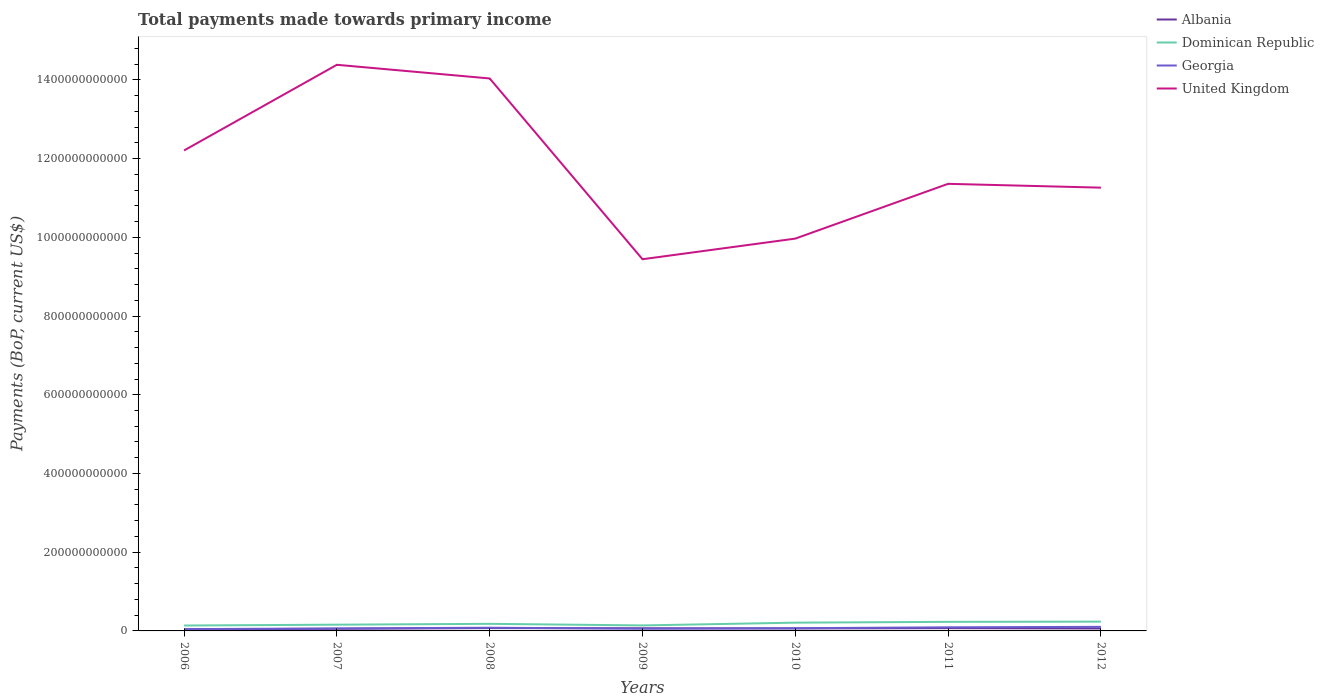Does the line corresponding to Dominican Republic intersect with the line corresponding to Albania?
Keep it short and to the point. No. Across all years, what is the maximum total payments made towards primary income in Georgia?
Your answer should be compact. 4.56e+09. In which year was the total payments made towards primary income in Albania maximum?
Give a very brief answer. 2006. What is the total total payments made towards primary income in United Kingdom in the graph?
Your answer should be very brief. -1.29e+11. What is the difference between the highest and the second highest total payments made towards primary income in Georgia?
Ensure brevity in your answer.  5.80e+09. Is the total payments made towards primary income in United Kingdom strictly greater than the total payments made towards primary income in Dominican Republic over the years?
Provide a short and direct response. No. How many lines are there?
Make the answer very short. 4. How many years are there in the graph?
Provide a succinct answer. 7. What is the difference between two consecutive major ticks on the Y-axis?
Ensure brevity in your answer.  2.00e+11. Are the values on the major ticks of Y-axis written in scientific E-notation?
Provide a succinct answer. No. Does the graph contain grids?
Provide a succinct answer. No. How are the legend labels stacked?
Provide a short and direct response. Vertical. What is the title of the graph?
Offer a terse response. Total payments made towards primary income. Does "Colombia" appear as one of the legend labels in the graph?
Your answer should be compact. No. What is the label or title of the Y-axis?
Offer a very short reply. Payments (BoP, current US$). What is the Payments (BoP, current US$) in Albania in 2006?
Ensure brevity in your answer.  4.14e+09. What is the Payments (BoP, current US$) of Dominican Republic in 2006?
Provide a succinct answer. 1.37e+1. What is the Payments (BoP, current US$) of Georgia in 2006?
Provide a short and direct response. 4.56e+09. What is the Payments (BoP, current US$) in United Kingdom in 2006?
Your answer should be compact. 1.22e+12. What is the Payments (BoP, current US$) in Albania in 2007?
Offer a very short reply. 5.43e+09. What is the Payments (BoP, current US$) of Dominican Republic in 2007?
Give a very brief answer. 1.59e+1. What is the Payments (BoP, current US$) in Georgia in 2007?
Your answer should be compact. 6.32e+09. What is the Payments (BoP, current US$) of United Kingdom in 2007?
Your answer should be very brief. 1.44e+12. What is the Payments (BoP, current US$) of Albania in 2008?
Your answer should be very brief. 7.15e+09. What is the Payments (BoP, current US$) of Dominican Republic in 2008?
Provide a succinct answer. 1.80e+1. What is the Payments (BoP, current US$) of Georgia in 2008?
Keep it short and to the point. 8.11e+09. What is the Payments (BoP, current US$) in United Kingdom in 2008?
Ensure brevity in your answer.  1.40e+12. What is the Payments (BoP, current US$) in Albania in 2009?
Provide a succinct answer. 6.60e+09. What is the Payments (BoP, current US$) in Dominican Republic in 2009?
Provide a succinct answer. 1.40e+1. What is the Payments (BoP, current US$) in Georgia in 2009?
Make the answer very short. 5.78e+09. What is the Payments (BoP, current US$) of United Kingdom in 2009?
Offer a very short reply. 9.44e+11. What is the Payments (BoP, current US$) of Albania in 2010?
Offer a very short reply. 6.28e+09. What is the Payments (BoP, current US$) in Dominican Republic in 2010?
Provide a short and direct response. 2.10e+1. What is the Payments (BoP, current US$) in Georgia in 2010?
Provide a short and direct response. 6.89e+09. What is the Payments (BoP, current US$) of United Kingdom in 2010?
Your answer should be compact. 9.97e+11. What is the Payments (BoP, current US$) in Albania in 2011?
Give a very brief answer. 7.01e+09. What is the Payments (BoP, current US$) in Dominican Republic in 2011?
Provide a short and direct response. 2.31e+1. What is the Payments (BoP, current US$) of Georgia in 2011?
Offer a very short reply. 9.17e+09. What is the Payments (BoP, current US$) in United Kingdom in 2011?
Make the answer very short. 1.14e+12. What is the Payments (BoP, current US$) in Albania in 2012?
Provide a short and direct response. 6.19e+09. What is the Payments (BoP, current US$) in Dominican Republic in 2012?
Ensure brevity in your answer.  2.36e+1. What is the Payments (BoP, current US$) of Georgia in 2012?
Provide a succinct answer. 1.04e+1. What is the Payments (BoP, current US$) in United Kingdom in 2012?
Provide a short and direct response. 1.13e+12. Across all years, what is the maximum Payments (BoP, current US$) of Albania?
Your answer should be very brief. 7.15e+09. Across all years, what is the maximum Payments (BoP, current US$) of Dominican Republic?
Give a very brief answer. 2.36e+1. Across all years, what is the maximum Payments (BoP, current US$) in Georgia?
Your response must be concise. 1.04e+1. Across all years, what is the maximum Payments (BoP, current US$) in United Kingdom?
Make the answer very short. 1.44e+12. Across all years, what is the minimum Payments (BoP, current US$) in Albania?
Keep it short and to the point. 4.14e+09. Across all years, what is the minimum Payments (BoP, current US$) of Dominican Republic?
Keep it short and to the point. 1.37e+1. Across all years, what is the minimum Payments (BoP, current US$) in Georgia?
Your answer should be very brief. 4.56e+09. Across all years, what is the minimum Payments (BoP, current US$) in United Kingdom?
Keep it short and to the point. 9.44e+11. What is the total Payments (BoP, current US$) in Albania in the graph?
Provide a succinct answer. 4.28e+1. What is the total Payments (BoP, current US$) of Dominican Republic in the graph?
Make the answer very short. 1.29e+11. What is the total Payments (BoP, current US$) in Georgia in the graph?
Make the answer very short. 5.12e+1. What is the total Payments (BoP, current US$) in United Kingdom in the graph?
Your answer should be compact. 8.27e+12. What is the difference between the Payments (BoP, current US$) of Albania in 2006 and that in 2007?
Make the answer very short. -1.29e+09. What is the difference between the Payments (BoP, current US$) in Dominican Republic in 2006 and that in 2007?
Your response must be concise. -2.16e+09. What is the difference between the Payments (BoP, current US$) of Georgia in 2006 and that in 2007?
Keep it short and to the point. -1.77e+09. What is the difference between the Payments (BoP, current US$) of United Kingdom in 2006 and that in 2007?
Make the answer very short. -2.18e+11. What is the difference between the Payments (BoP, current US$) of Albania in 2006 and that in 2008?
Give a very brief answer. -3.01e+09. What is the difference between the Payments (BoP, current US$) of Dominican Republic in 2006 and that in 2008?
Keep it short and to the point. -4.31e+09. What is the difference between the Payments (BoP, current US$) in Georgia in 2006 and that in 2008?
Give a very brief answer. -3.56e+09. What is the difference between the Payments (BoP, current US$) of United Kingdom in 2006 and that in 2008?
Offer a terse response. -1.83e+11. What is the difference between the Payments (BoP, current US$) in Albania in 2006 and that in 2009?
Provide a succinct answer. -2.46e+09. What is the difference between the Payments (BoP, current US$) in Dominican Republic in 2006 and that in 2009?
Offer a very short reply. -2.64e+08. What is the difference between the Payments (BoP, current US$) of Georgia in 2006 and that in 2009?
Keep it short and to the point. -1.22e+09. What is the difference between the Payments (BoP, current US$) of United Kingdom in 2006 and that in 2009?
Give a very brief answer. 2.76e+11. What is the difference between the Payments (BoP, current US$) of Albania in 2006 and that in 2010?
Your answer should be compact. -2.14e+09. What is the difference between the Payments (BoP, current US$) of Dominican Republic in 2006 and that in 2010?
Ensure brevity in your answer.  -7.26e+09. What is the difference between the Payments (BoP, current US$) in Georgia in 2006 and that in 2010?
Your answer should be very brief. -2.33e+09. What is the difference between the Payments (BoP, current US$) in United Kingdom in 2006 and that in 2010?
Keep it short and to the point. 2.24e+11. What is the difference between the Payments (BoP, current US$) of Albania in 2006 and that in 2011?
Offer a very short reply. -2.87e+09. What is the difference between the Payments (BoP, current US$) of Dominican Republic in 2006 and that in 2011?
Provide a succinct answer. -9.36e+09. What is the difference between the Payments (BoP, current US$) in Georgia in 2006 and that in 2011?
Offer a terse response. -4.61e+09. What is the difference between the Payments (BoP, current US$) of United Kingdom in 2006 and that in 2011?
Offer a very short reply. 8.48e+1. What is the difference between the Payments (BoP, current US$) of Albania in 2006 and that in 2012?
Give a very brief answer. -2.05e+09. What is the difference between the Payments (BoP, current US$) in Dominican Republic in 2006 and that in 2012?
Provide a short and direct response. -9.91e+09. What is the difference between the Payments (BoP, current US$) in Georgia in 2006 and that in 2012?
Provide a succinct answer. -5.80e+09. What is the difference between the Payments (BoP, current US$) of United Kingdom in 2006 and that in 2012?
Give a very brief answer. 9.45e+1. What is the difference between the Payments (BoP, current US$) in Albania in 2007 and that in 2008?
Your response must be concise. -1.72e+09. What is the difference between the Payments (BoP, current US$) in Dominican Republic in 2007 and that in 2008?
Provide a short and direct response. -2.15e+09. What is the difference between the Payments (BoP, current US$) in Georgia in 2007 and that in 2008?
Provide a short and direct response. -1.79e+09. What is the difference between the Payments (BoP, current US$) of United Kingdom in 2007 and that in 2008?
Offer a terse response. 3.47e+1. What is the difference between the Payments (BoP, current US$) in Albania in 2007 and that in 2009?
Offer a very short reply. -1.17e+09. What is the difference between the Payments (BoP, current US$) of Dominican Republic in 2007 and that in 2009?
Give a very brief answer. 1.90e+09. What is the difference between the Payments (BoP, current US$) of Georgia in 2007 and that in 2009?
Offer a terse response. 5.46e+08. What is the difference between the Payments (BoP, current US$) in United Kingdom in 2007 and that in 2009?
Offer a terse response. 4.94e+11. What is the difference between the Payments (BoP, current US$) in Albania in 2007 and that in 2010?
Keep it short and to the point. -8.50e+08. What is the difference between the Payments (BoP, current US$) in Dominican Republic in 2007 and that in 2010?
Give a very brief answer. -5.10e+09. What is the difference between the Payments (BoP, current US$) in Georgia in 2007 and that in 2010?
Ensure brevity in your answer.  -5.60e+08. What is the difference between the Payments (BoP, current US$) of United Kingdom in 2007 and that in 2010?
Your response must be concise. 4.42e+11. What is the difference between the Payments (BoP, current US$) in Albania in 2007 and that in 2011?
Provide a succinct answer. -1.58e+09. What is the difference between the Payments (BoP, current US$) of Dominican Republic in 2007 and that in 2011?
Offer a terse response. -7.20e+09. What is the difference between the Payments (BoP, current US$) in Georgia in 2007 and that in 2011?
Offer a terse response. -2.84e+09. What is the difference between the Payments (BoP, current US$) in United Kingdom in 2007 and that in 2011?
Offer a terse response. 3.02e+11. What is the difference between the Payments (BoP, current US$) in Albania in 2007 and that in 2012?
Your answer should be very brief. -7.60e+08. What is the difference between the Payments (BoP, current US$) in Dominican Republic in 2007 and that in 2012?
Make the answer very short. -7.75e+09. What is the difference between the Payments (BoP, current US$) in Georgia in 2007 and that in 2012?
Offer a terse response. -4.03e+09. What is the difference between the Payments (BoP, current US$) in United Kingdom in 2007 and that in 2012?
Ensure brevity in your answer.  3.12e+11. What is the difference between the Payments (BoP, current US$) in Albania in 2008 and that in 2009?
Your answer should be very brief. 5.51e+08. What is the difference between the Payments (BoP, current US$) in Dominican Republic in 2008 and that in 2009?
Your answer should be compact. 4.04e+09. What is the difference between the Payments (BoP, current US$) in Georgia in 2008 and that in 2009?
Provide a short and direct response. 2.34e+09. What is the difference between the Payments (BoP, current US$) in United Kingdom in 2008 and that in 2009?
Your answer should be very brief. 4.59e+11. What is the difference between the Payments (BoP, current US$) in Albania in 2008 and that in 2010?
Your answer should be compact. 8.69e+08. What is the difference between the Payments (BoP, current US$) in Dominican Republic in 2008 and that in 2010?
Your answer should be compact. -2.95e+09. What is the difference between the Payments (BoP, current US$) in Georgia in 2008 and that in 2010?
Make the answer very short. 1.23e+09. What is the difference between the Payments (BoP, current US$) of United Kingdom in 2008 and that in 2010?
Offer a very short reply. 4.07e+11. What is the difference between the Payments (BoP, current US$) of Albania in 2008 and that in 2011?
Your answer should be compact. 1.39e+08. What is the difference between the Payments (BoP, current US$) of Dominican Republic in 2008 and that in 2011?
Make the answer very short. -5.05e+09. What is the difference between the Payments (BoP, current US$) in Georgia in 2008 and that in 2011?
Give a very brief answer. -1.05e+09. What is the difference between the Payments (BoP, current US$) in United Kingdom in 2008 and that in 2011?
Your answer should be compact. 2.68e+11. What is the difference between the Payments (BoP, current US$) of Albania in 2008 and that in 2012?
Give a very brief answer. 9.60e+08. What is the difference between the Payments (BoP, current US$) in Dominican Republic in 2008 and that in 2012?
Keep it short and to the point. -5.60e+09. What is the difference between the Payments (BoP, current US$) of Georgia in 2008 and that in 2012?
Provide a short and direct response. -2.24e+09. What is the difference between the Payments (BoP, current US$) in United Kingdom in 2008 and that in 2012?
Give a very brief answer. 2.77e+11. What is the difference between the Payments (BoP, current US$) of Albania in 2009 and that in 2010?
Keep it short and to the point. 3.18e+08. What is the difference between the Payments (BoP, current US$) of Dominican Republic in 2009 and that in 2010?
Ensure brevity in your answer.  -7.00e+09. What is the difference between the Payments (BoP, current US$) of Georgia in 2009 and that in 2010?
Offer a terse response. -1.11e+09. What is the difference between the Payments (BoP, current US$) of United Kingdom in 2009 and that in 2010?
Keep it short and to the point. -5.24e+1. What is the difference between the Payments (BoP, current US$) in Albania in 2009 and that in 2011?
Make the answer very short. -4.12e+08. What is the difference between the Payments (BoP, current US$) in Dominican Republic in 2009 and that in 2011?
Your answer should be very brief. -9.09e+09. What is the difference between the Payments (BoP, current US$) of Georgia in 2009 and that in 2011?
Provide a short and direct response. -3.39e+09. What is the difference between the Payments (BoP, current US$) of United Kingdom in 2009 and that in 2011?
Your response must be concise. -1.92e+11. What is the difference between the Payments (BoP, current US$) in Albania in 2009 and that in 2012?
Ensure brevity in your answer.  4.09e+08. What is the difference between the Payments (BoP, current US$) of Dominican Republic in 2009 and that in 2012?
Your answer should be very brief. -9.65e+09. What is the difference between the Payments (BoP, current US$) in Georgia in 2009 and that in 2012?
Give a very brief answer. -4.58e+09. What is the difference between the Payments (BoP, current US$) in United Kingdom in 2009 and that in 2012?
Keep it short and to the point. -1.82e+11. What is the difference between the Payments (BoP, current US$) of Albania in 2010 and that in 2011?
Provide a succinct answer. -7.30e+08. What is the difference between the Payments (BoP, current US$) in Dominican Republic in 2010 and that in 2011?
Ensure brevity in your answer.  -2.10e+09. What is the difference between the Payments (BoP, current US$) in Georgia in 2010 and that in 2011?
Provide a short and direct response. -2.28e+09. What is the difference between the Payments (BoP, current US$) in United Kingdom in 2010 and that in 2011?
Offer a terse response. -1.39e+11. What is the difference between the Payments (BoP, current US$) of Albania in 2010 and that in 2012?
Your answer should be compact. 9.08e+07. What is the difference between the Payments (BoP, current US$) of Dominican Republic in 2010 and that in 2012?
Your answer should be very brief. -2.65e+09. What is the difference between the Payments (BoP, current US$) of Georgia in 2010 and that in 2012?
Make the answer very short. -3.47e+09. What is the difference between the Payments (BoP, current US$) in United Kingdom in 2010 and that in 2012?
Make the answer very short. -1.29e+11. What is the difference between the Payments (BoP, current US$) of Albania in 2011 and that in 2012?
Your response must be concise. 8.21e+08. What is the difference between the Payments (BoP, current US$) of Dominican Republic in 2011 and that in 2012?
Ensure brevity in your answer.  -5.53e+08. What is the difference between the Payments (BoP, current US$) in Georgia in 2011 and that in 2012?
Your answer should be very brief. -1.19e+09. What is the difference between the Payments (BoP, current US$) in United Kingdom in 2011 and that in 2012?
Ensure brevity in your answer.  9.73e+09. What is the difference between the Payments (BoP, current US$) of Albania in 2006 and the Payments (BoP, current US$) of Dominican Republic in 2007?
Make the answer very short. -1.17e+1. What is the difference between the Payments (BoP, current US$) in Albania in 2006 and the Payments (BoP, current US$) in Georgia in 2007?
Your response must be concise. -2.18e+09. What is the difference between the Payments (BoP, current US$) in Albania in 2006 and the Payments (BoP, current US$) in United Kingdom in 2007?
Your answer should be very brief. -1.43e+12. What is the difference between the Payments (BoP, current US$) of Dominican Republic in 2006 and the Payments (BoP, current US$) of Georgia in 2007?
Give a very brief answer. 7.40e+09. What is the difference between the Payments (BoP, current US$) of Dominican Republic in 2006 and the Payments (BoP, current US$) of United Kingdom in 2007?
Provide a succinct answer. -1.42e+12. What is the difference between the Payments (BoP, current US$) of Georgia in 2006 and the Payments (BoP, current US$) of United Kingdom in 2007?
Provide a succinct answer. -1.43e+12. What is the difference between the Payments (BoP, current US$) of Albania in 2006 and the Payments (BoP, current US$) of Dominican Republic in 2008?
Offer a terse response. -1.39e+1. What is the difference between the Payments (BoP, current US$) in Albania in 2006 and the Payments (BoP, current US$) in Georgia in 2008?
Give a very brief answer. -3.97e+09. What is the difference between the Payments (BoP, current US$) of Albania in 2006 and the Payments (BoP, current US$) of United Kingdom in 2008?
Keep it short and to the point. -1.40e+12. What is the difference between the Payments (BoP, current US$) in Dominican Republic in 2006 and the Payments (BoP, current US$) in Georgia in 2008?
Provide a succinct answer. 5.61e+09. What is the difference between the Payments (BoP, current US$) of Dominican Republic in 2006 and the Payments (BoP, current US$) of United Kingdom in 2008?
Keep it short and to the point. -1.39e+12. What is the difference between the Payments (BoP, current US$) in Georgia in 2006 and the Payments (BoP, current US$) in United Kingdom in 2008?
Provide a short and direct response. -1.40e+12. What is the difference between the Payments (BoP, current US$) of Albania in 2006 and the Payments (BoP, current US$) of Dominican Republic in 2009?
Your response must be concise. -9.84e+09. What is the difference between the Payments (BoP, current US$) of Albania in 2006 and the Payments (BoP, current US$) of Georgia in 2009?
Offer a very short reply. -1.64e+09. What is the difference between the Payments (BoP, current US$) of Albania in 2006 and the Payments (BoP, current US$) of United Kingdom in 2009?
Your response must be concise. -9.40e+11. What is the difference between the Payments (BoP, current US$) in Dominican Republic in 2006 and the Payments (BoP, current US$) in Georgia in 2009?
Give a very brief answer. 7.94e+09. What is the difference between the Payments (BoP, current US$) in Dominican Republic in 2006 and the Payments (BoP, current US$) in United Kingdom in 2009?
Offer a terse response. -9.31e+11. What is the difference between the Payments (BoP, current US$) of Georgia in 2006 and the Payments (BoP, current US$) of United Kingdom in 2009?
Your answer should be very brief. -9.40e+11. What is the difference between the Payments (BoP, current US$) in Albania in 2006 and the Payments (BoP, current US$) in Dominican Republic in 2010?
Your answer should be compact. -1.68e+1. What is the difference between the Payments (BoP, current US$) in Albania in 2006 and the Payments (BoP, current US$) in Georgia in 2010?
Keep it short and to the point. -2.74e+09. What is the difference between the Payments (BoP, current US$) of Albania in 2006 and the Payments (BoP, current US$) of United Kingdom in 2010?
Keep it short and to the point. -9.93e+11. What is the difference between the Payments (BoP, current US$) of Dominican Republic in 2006 and the Payments (BoP, current US$) of Georgia in 2010?
Provide a short and direct response. 6.84e+09. What is the difference between the Payments (BoP, current US$) in Dominican Republic in 2006 and the Payments (BoP, current US$) in United Kingdom in 2010?
Provide a succinct answer. -9.83e+11. What is the difference between the Payments (BoP, current US$) of Georgia in 2006 and the Payments (BoP, current US$) of United Kingdom in 2010?
Keep it short and to the point. -9.92e+11. What is the difference between the Payments (BoP, current US$) of Albania in 2006 and the Payments (BoP, current US$) of Dominican Republic in 2011?
Give a very brief answer. -1.89e+1. What is the difference between the Payments (BoP, current US$) of Albania in 2006 and the Payments (BoP, current US$) of Georgia in 2011?
Your answer should be compact. -5.03e+09. What is the difference between the Payments (BoP, current US$) in Albania in 2006 and the Payments (BoP, current US$) in United Kingdom in 2011?
Make the answer very short. -1.13e+12. What is the difference between the Payments (BoP, current US$) of Dominican Republic in 2006 and the Payments (BoP, current US$) of Georgia in 2011?
Your answer should be compact. 4.55e+09. What is the difference between the Payments (BoP, current US$) of Dominican Republic in 2006 and the Payments (BoP, current US$) of United Kingdom in 2011?
Ensure brevity in your answer.  -1.12e+12. What is the difference between the Payments (BoP, current US$) in Georgia in 2006 and the Payments (BoP, current US$) in United Kingdom in 2011?
Your response must be concise. -1.13e+12. What is the difference between the Payments (BoP, current US$) of Albania in 2006 and the Payments (BoP, current US$) of Dominican Republic in 2012?
Provide a short and direct response. -1.95e+1. What is the difference between the Payments (BoP, current US$) in Albania in 2006 and the Payments (BoP, current US$) in Georgia in 2012?
Make the answer very short. -6.21e+09. What is the difference between the Payments (BoP, current US$) in Albania in 2006 and the Payments (BoP, current US$) in United Kingdom in 2012?
Offer a terse response. -1.12e+12. What is the difference between the Payments (BoP, current US$) of Dominican Republic in 2006 and the Payments (BoP, current US$) of Georgia in 2012?
Provide a succinct answer. 3.37e+09. What is the difference between the Payments (BoP, current US$) in Dominican Republic in 2006 and the Payments (BoP, current US$) in United Kingdom in 2012?
Ensure brevity in your answer.  -1.11e+12. What is the difference between the Payments (BoP, current US$) in Georgia in 2006 and the Payments (BoP, current US$) in United Kingdom in 2012?
Your response must be concise. -1.12e+12. What is the difference between the Payments (BoP, current US$) of Albania in 2007 and the Payments (BoP, current US$) of Dominican Republic in 2008?
Provide a succinct answer. -1.26e+1. What is the difference between the Payments (BoP, current US$) of Albania in 2007 and the Payments (BoP, current US$) of Georgia in 2008?
Give a very brief answer. -2.69e+09. What is the difference between the Payments (BoP, current US$) of Albania in 2007 and the Payments (BoP, current US$) of United Kingdom in 2008?
Your answer should be compact. -1.40e+12. What is the difference between the Payments (BoP, current US$) in Dominican Republic in 2007 and the Payments (BoP, current US$) in Georgia in 2008?
Provide a succinct answer. 7.77e+09. What is the difference between the Payments (BoP, current US$) of Dominican Republic in 2007 and the Payments (BoP, current US$) of United Kingdom in 2008?
Give a very brief answer. -1.39e+12. What is the difference between the Payments (BoP, current US$) of Georgia in 2007 and the Payments (BoP, current US$) of United Kingdom in 2008?
Offer a terse response. -1.40e+12. What is the difference between the Payments (BoP, current US$) in Albania in 2007 and the Payments (BoP, current US$) in Dominican Republic in 2009?
Your response must be concise. -8.56e+09. What is the difference between the Payments (BoP, current US$) of Albania in 2007 and the Payments (BoP, current US$) of Georgia in 2009?
Make the answer very short. -3.50e+08. What is the difference between the Payments (BoP, current US$) of Albania in 2007 and the Payments (BoP, current US$) of United Kingdom in 2009?
Give a very brief answer. -9.39e+11. What is the difference between the Payments (BoP, current US$) of Dominican Republic in 2007 and the Payments (BoP, current US$) of Georgia in 2009?
Offer a very short reply. 1.01e+1. What is the difference between the Payments (BoP, current US$) of Dominican Republic in 2007 and the Payments (BoP, current US$) of United Kingdom in 2009?
Your answer should be compact. -9.28e+11. What is the difference between the Payments (BoP, current US$) of Georgia in 2007 and the Payments (BoP, current US$) of United Kingdom in 2009?
Offer a very short reply. -9.38e+11. What is the difference between the Payments (BoP, current US$) of Albania in 2007 and the Payments (BoP, current US$) of Dominican Republic in 2010?
Your answer should be very brief. -1.56e+1. What is the difference between the Payments (BoP, current US$) in Albania in 2007 and the Payments (BoP, current US$) in Georgia in 2010?
Offer a terse response. -1.46e+09. What is the difference between the Payments (BoP, current US$) in Albania in 2007 and the Payments (BoP, current US$) in United Kingdom in 2010?
Your answer should be very brief. -9.91e+11. What is the difference between the Payments (BoP, current US$) in Dominican Republic in 2007 and the Payments (BoP, current US$) in Georgia in 2010?
Provide a succinct answer. 9.00e+09. What is the difference between the Payments (BoP, current US$) of Dominican Republic in 2007 and the Payments (BoP, current US$) of United Kingdom in 2010?
Your answer should be very brief. -9.81e+11. What is the difference between the Payments (BoP, current US$) of Georgia in 2007 and the Payments (BoP, current US$) of United Kingdom in 2010?
Your answer should be very brief. -9.90e+11. What is the difference between the Payments (BoP, current US$) of Albania in 2007 and the Payments (BoP, current US$) of Dominican Republic in 2011?
Your answer should be compact. -1.77e+1. What is the difference between the Payments (BoP, current US$) in Albania in 2007 and the Payments (BoP, current US$) in Georgia in 2011?
Your answer should be very brief. -3.74e+09. What is the difference between the Payments (BoP, current US$) in Albania in 2007 and the Payments (BoP, current US$) in United Kingdom in 2011?
Your answer should be very brief. -1.13e+12. What is the difference between the Payments (BoP, current US$) in Dominican Republic in 2007 and the Payments (BoP, current US$) in Georgia in 2011?
Offer a terse response. 6.71e+09. What is the difference between the Payments (BoP, current US$) in Dominican Republic in 2007 and the Payments (BoP, current US$) in United Kingdom in 2011?
Your answer should be compact. -1.12e+12. What is the difference between the Payments (BoP, current US$) in Georgia in 2007 and the Payments (BoP, current US$) in United Kingdom in 2011?
Your answer should be very brief. -1.13e+12. What is the difference between the Payments (BoP, current US$) in Albania in 2007 and the Payments (BoP, current US$) in Dominican Republic in 2012?
Your answer should be compact. -1.82e+1. What is the difference between the Payments (BoP, current US$) of Albania in 2007 and the Payments (BoP, current US$) of Georgia in 2012?
Make the answer very short. -4.93e+09. What is the difference between the Payments (BoP, current US$) in Albania in 2007 and the Payments (BoP, current US$) in United Kingdom in 2012?
Keep it short and to the point. -1.12e+12. What is the difference between the Payments (BoP, current US$) in Dominican Republic in 2007 and the Payments (BoP, current US$) in Georgia in 2012?
Give a very brief answer. 5.52e+09. What is the difference between the Payments (BoP, current US$) of Dominican Republic in 2007 and the Payments (BoP, current US$) of United Kingdom in 2012?
Provide a succinct answer. -1.11e+12. What is the difference between the Payments (BoP, current US$) of Georgia in 2007 and the Payments (BoP, current US$) of United Kingdom in 2012?
Your answer should be very brief. -1.12e+12. What is the difference between the Payments (BoP, current US$) in Albania in 2008 and the Payments (BoP, current US$) in Dominican Republic in 2009?
Your answer should be very brief. -6.84e+09. What is the difference between the Payments (BoP, current US$) of Albania in 2008 and the Payments (BoP, current US$) of Georgia in 2009?
Your answer should be compact. 1.37e+09. What is the difference between the Payments (BoP, current US$) in Albania in 2008 and the Payments (BoP, current US$) in United Kingdom in 2009?
Provide a short and direct response. -9.37e+11. What is the difference between the Payments (BoP, current US$) of Dominican Republic in 2008 and the Payments (BoP, current US$) of Georgia in 2009?
Make the answer very short. 1.23e+1. What is the difference between the Payments (BoP, current US$) in Dominican Republic in 2008 and the Payments (BoP, current US$) in United Kingdom in 2009?
Make the answer very short. -9.26e+11. What is the difference between the Payments (BoP, current US$) of Georgia in 2008 and the Payments (BoP, current US$) of United Kingdom in 2009?
Your answer should be compact. -9.36e+11. What is the difference between the Payments (BoP, current US$) of Albania in 2008 and the Payments (BoP, current US$) of Dominican Republic in 2010?
Provide a succinct answer. -1.38e+1. What is the difference between the Payments (BoP, current US$) in Albania in 2008 and the Payments (BoP, current US$) in Georgia in 2010?
Ensure brevity in your answer.  2.64e+08. What is the difference between the Payments (BoP, current US$) of Albania in 2008 and the Payments (BoP, current US$) of United Kingdom in 2010?
Offer a very short reply. -9.90e+11. What is the difference between the Payments (BoP, current US$) of Dominican Republic in 2008 and the Payments (BoP, current US$) of Georgia in 2010?
Offer a very short reply. 1.11e+1. What is the difference between the Payments (BoP, current US$) of Dominican Republic in 2008 and the Payments (BoP, current US$) of United Kingdom in 2010?
Offer a terse response. -9.79e+11. What is the difference between the Payments (BoP, current US$) in Georgia in 2008 and the Payments (BoP, current US$) in United Kingdom in 2010?
Provide a succinct answer. -9.89e+11. What is the difference between the Payments (BoP, current US$) in Albania in 2008 and the Payments (BoP, current US$) in Dominican Republic in 2011?
Make the answer very short. -1.59e+1. What is the difference between the Payments (BoP, current US$) of Albania in 2008 and the Payments (BoP, current US$) of Georgia in 2011?
Give a very brief answer. -2.02e+09. What is the difference between the Payments (BoP, current US$) of Albania in 2008 and the Payments (BoP, current US$) of United Kingdom in 2011?
Provide a short and direct response. -1.13e+12. What is the difference between the Payments (BoP, current US$) in Dominican Republic in 2008 and the Payments (BoP, current US$) in Georgia in 2011?
Provide a short and direct response. 8.86e+09. What is the difference between the Payments (BoP, current US$) of Dominican Republic in 2008 and the Payments (BoP, current US$) of United Kingdom in 2011?
Give a very brief answer. -1.12e+12. What is the difference between the Payments (BoP, current US$) of Georgia in 2008 and the Payments (BoP, current US$) of United Kingdom in 2011?
Your answer should be very brief. -1.13e+12. What is the difference between the Payments (BoP, current US$) in Albania in 2008 and the Payments (BoP, current US$) in Dominican Republic in 2012?
Offer a very short reply. -1.65e+1. What is the difference between the Payments (BoP, current US$) in Albania in 2008 and the Payments (BoP, current US$) in Georgia in 2012?
Make the answer very short. -3.21e+09. What is the difference between the Payments (BoP, current US$) of Albania in 2008 and the Payments (BoP, current US$) of United Kingdom in 2012?
Ensure brevity in your answer.  -1.12e+12. What is the difference between the Payments (BoP, current US$) in Dominican Republic in 2008 and the Payments (BoP, current US$) in Georgia in 2012?
Ensure brevity in your answer.  7.67e+09. What is the difference between the Payments (BoP, current US$) in Dominican Republic in 2008 and the Payments (BoP, current US$) in United Kingdom in 2012?
Offer a very short reply. -1.11e+12. What is the difference between the Payments (BoP, current US$) of Georgia in 2008 and the Payments (BoP, current US$) of United Kingdom in 2012?
Keep it short and to the point. -1.12e+12. What is the difference between the Payments (BoP, current US$) in Albania in 2009 and the Payments (BoP, current US$) in Dominican Republic in 2010?
Offer a terse response. -1.44e+1. What is the difference between the Payments (BoP, current US$) in Albania in 2009 and the Payments (BoP, current US$) in Georgia in 2010?
Keep it short and to the point. -2.87e+08. What is the difference between the Payments (BoP, current US$) of Albania in 2009 and the Payments (BoP, current US$) of United Kingdom in 2010?
Make the answer very short. -9.90e+11. What is the difference between the Payments (BoP, current US$) of Dominican Republic in 2009 and the Payments (BoP, current US$) of Georgia in 2010?
Offer a very short reply. 7.10e+09. What is the difference between the Payments (BoP, current US$) of Dominican Republic in 2009 and the Payments (BoP, current US$) of United Kingdom in 2010?
Provide a short and direct response. -9.83e+11. What is the difference between the Payments (BoP, current US$) of Georgia in 2009 and the Payments (BoP, current US$) of United Kingdom in 2010?
Give a very brief answer. -9.91e+11. What is the difference between the Payments (BoP, current US$) in Albania in 2009 and the Payments (BoP, current US$) in Dominican Republic in 2011?
Provide a succinct answer. -1.65e+1. What is the difference between the Payments (BoP, current US$) in Albania in 2009 and the Payments (BoP, current US$) in Georgia in 2011?
Ensure brevity in your answer.  -2.57e+09. What is the difference between the Payments (BoP, current US$) of Albania in 2009 and the Payments (BoP, current US$) of United Kingdom in 2011?
Your response must be concise. -1.13e+12. What is the difference between the Payments (BoP, current US$) of Dominican Republic in 2009 and the Payments (BoP, current US$) of Georgia in 2011?
Your answer should be compact. 4.82e+09. What is the difference between the Payments (BoP, current US$) of Dominican Republic in 2009 and the Payments (BoP, current US$) of United Kingdom in 2011?
Give a very brief answer. -1.12e+12. What is the difference between the Payments (BoP, current US$) in Georgia in 2009 and the Payments (BoP, current US$) in United Kingdom in 2011?
Your answer should be very brief. -1.13e+12. What is the difference between the Payments (BoP, current US$) in Albania in 2009 and the Payments (BoP, current US$) in Dominican Republic in 2012?
Ensure brevity in your answer.  -1.70e+1. What is the difference between the Payments (BoP, current US$) in Albania in 2009 and the Payments (BoP, current US$) in Georgia in 2012?
Keep it short and to the point. -3.76e+09. What is the difference between the Payments (BoP, current US$) in Albania in 2009 and the Payments (BoP, current US$) in United Kingdom in 2012?
Offer a very short reply. -1.12e+12. What is the difference between the Payments (BoP, current US$) of Dominican Republic in 2009 and the Payments (BoP, current US$) of Georgia in 2012?
Ensure brevity in your answer.  3.63e+09. What is the difference between the Payments (BoP, current US$) of Dominican Republic in 2009 and the Payments (BoP, current US$) of United Kingdom in 2012?
Provide a short and direct response. -1.11e+12. What is the difference between the Payments (BoP, current US$) in Georgia in 2009 and the Payments (BoP, current US$) in United Kingdom in 2012?
Give a very brief answer. -1.12e+12. What is the difference between the Payments (BoP, current US$) in Albania in 2010 and the Payments (BoP, current US$) in Dominican Republic in 2011?
Provide a short and direct response. -1.68e+1. What is the difference between the Payments (BoP, current US$) in Albania in 2010 and the Payments (BoP, current US$) in Georgia in 2011?
Your answer should be compact. -2.89e+09. What is the difference between the Payments (BoP, current US$) of Albania in 2010 and the Payments (BoP, current US$) of United Kingdom in 2011?
Your answer should be very brief. -1.13e+12. What is the difference between the Payments (BoP, current US$) of Dominican Republic in 2010 and the Payments (BoP, current US$) of Georgia in 2011?
Provide a succinct answer. 1.18e+1. What is the difference between the Payments (BoP, current US$) of Dominican Republic in 2010 and the Payments (BoP, current US$) of United Kingdom in 2011?
Keep it short and to the point. -1.11e+12. What is the difference between the Payments (BoP, current US$) of Georgia in 2010 and the Payments (BoP, current US$) of United Kingdom in 2011?
Your response must be concise. -1.13e+12. What is the difference between the Payments (BoP, current US$) in Albania in 2010 and the Payments (BoP, current US$) in Dominican Republic in 2012?
Make the answer very short. -1.74e+1. What is the difference between the Payments (BoP, current US$) of Albania in 2010 and the Payments (BoP, current US$) of Georgia in 2012?
Offer a very short reply. -4.08e+09. What is the difference between the Payments (BoP, current US$) in Albania in 2010 and the Payments (BoP, current US$) in United Kingdom in 2012?
Make the answer very short. -1.12e+12. What is the difference between the Payments (BoP, current US$) of Dominican Republic in 2010 and the Payments (BoP, current US$) of Georgia in 2012?
Give a very brief answer. 1.06e+1. What is the difference between the Payments (BoP, current US$) in Dominican Republic in 2010 and the Payments (BoP, current US$) in United Kingdom in 2012?
Ensure brevity in your answer.  -1.11e+12. What is the difference between the Payments (BoP, current US$) in Georgia in 2010 and the Payments (BoP, current US$) in United Kingdom in 2012?
Provide a succinct answer. -1.12e+12. What is the difference between the Payments (BoP, current US$) in Albania in 2011 and the Payments (BoP, current US$) in Dominican Republic in 2012?
Make the answer very short. -1.66e+1. What is the difference between the Payments (BoP, current US$) in Albania in 2011 and the Payments (BoP, current US$) in Georgia in 2012?
Your response must be concise. -3.35e+09. What is the difference between the Payments (BoP, current US$) of Albania in 2011 and the Payments (BoP, current US$) of United Kingdom in 2012?
Your answer should be very brief. -1.12e+12. What is the difference between the Payments (BoP, current US$) in Dominican Republic in 2011 and the Payments (BoP, current US$) in Georgia in 2012?
Give a very brief answer. 1.27e+1. What is the difference between the Payments (BoP, current US$) of Dominican Republic in 2011 and the Payments (BoP, current US$) of United Kingdom in 2012?
Offer a very short reply. -1.10e+12. What is the difference between the Payments (BoP, current US$) in Georgia in 2011 and the Payments (BoP, current US$) in United Kingdom in 2012?
Give a very brief answer. -1.12e+12. What is the average Payments (BoP, current US$) in Albania per year?
Ensure brevity in your answer.  6.11e+09. What is the average Payments (BoP, current US$) of Dominican Republic per year?
Your response must be concise. 1.85e+1. What is the average Payments (BoP, current US$) in Georgia per year?
Your response must be concise. 7.31e+09. What is the average Payments (BoP, current US$) in United Kingdom per year?
Provide a short and direct response. 1.18e+12. In the year 2006, what is the difference between the Payments (BoP, current US$) in Albania and Payments (BoP, current US$) in Dominican Republic?
Your answer should be compact. -9.58e+09. In the year 2006, what is the difference between the Payments (BoP, current US$) in Albania and Payments (BoP, current US$) in Georgia?
Provide a succinct answer. -4.13e+08. In the year 2006, what is the difference between the Payments (BoP, current US$) of Albania and Payments (BoP, current US$) of United Kingdom?
Provide a short and direct response. -1.22e+12. In the year 2006, what is the difference between the Payments (BoP, current US$) of Dominican Republic and Payments (BoP, current US$) of Georgia?
Make the answer very short. 9.17e+09. In the year 2006, what is the difference between the Payments (BoP, current US$) of Dominican Republic and Payments (BoP, current US$) of United Kingdom?
Your response must be concise. -1.21e+12. In the year 2006, what is the difference between the Payments (BoP, current US$) of Georgia and Payments (BoP, current US$) of United Kingdom?
Offer a very short reply. -1.22e+12. In the year 2007, what is the difference between the Payments (BoP, current US$) of Albania and Payments (BoP, current US$) of Dominican Republic?
Ensure brevity in your answer.  -1.05e+1. In the year 2007, what is the difference between the Payments (BoP, current US$) of Albania and Payments (BoP, current US$) of Georgia?
Make the answer very short. -8.96e+08. In the year 2007, what is the difference between the Payments (BoP, current US$) of Albania and Payments (BoP, current US$) of United Kingdom?
Ensure brevity in your answer.  -1.43e+12. In the year 2007, what is the difference between the Payments (BoP, current US$) of Dominican Republic and Payments (BoP, current US$) of Georgia?
Your answer should be very brief. 9.56e+09. In the year 2007, what is the difference between the Payments (BoP, current US$) of Dominican Republic and Payments (BoP, current US$) of United Kingdom?
Your response must be concise. -1.42e+12. In the year 2007, what is the difference between the Payments (BoP, current US$) in Georgia and Payments (BoP, current US$) in United Kingdom?
Offer a terse response. -1.43e+12. In the year 2008, what is the difference between the Payments (BoP, current US$) in Albania and Payments (BoP, current US$) in Dominican Republic?
Your response must be concise. -1.09e+1. In the year 2008, what is the difference between the Payments (BoP, current US$) in Albania and Payments (BoP, current US$) in Georgia?
Your answer should be compact. -9.66e+08. In the year 2008, what is the difference between the Payments (BoP, current US$) of Albania and Payments (BoP, current US$) of United Kingdom?
Keep it short and to the point. -1.40e+12. In the year 2008, what is the difference between the Payments (BoP, current US$) in Dominican Republic and Payments (BoP, current US$) in Georgia?
Your answer should be very brief. 9.92e+09. In the year 2008, what is the difference between the Payments (BoP, current US$) of Dominican Republic and Payments (BoP, current US$) of United Kingdom?
Provide a short and direct response. -1.39e+12. In the year 2008, what is the difference between the Payments (BoP, current US$) of Georgia and Payments (BoP, current US$) of United Kingdom?
Your answer should be compact. -1.40e+12. In the year 2009, what is the difference between the Payments (BoP, current US$) in Albania and Payments (BoP, current US$) in Dominican Republic?
Ensure brevity in your answer.  -7.39e+09. In the year 2009, what is the difference between the Payments (BoP, current US$) of Albania and Payments (BoP, current US$) of Georgia?
Make the answer very short. 8.19e+08. In the year 2009, what is the difference between the Payments (BoP, current US$) in Albania and Payments (BoP, current US$) in United Kingdom?
Keep it short and to the point. -9.38e+11. In the year 2009, what is the difference between the Payments (BoP, current US$) of Dominican Republic and Payments (BoP, current US$) of Georgia?
Offer a terse response. 8.21e+09. In the year 2009, what is the difference between the Payments (BoP, current US$) of Dominican Republic and Payments (BoP, current US$) of United Kingdom?
Provide a succinct answer. -9.30e+11. In the year 2009, what is the difference between the Payments (BoP, current US$) of Georgia and Payments (BoP, current US$) of United Kingdom?
Give a very brief answer. -9.39e+11. In the year 2010, what is the difference between the Payments (BoP, current US$) in Albania and Payments (BoP, current US$) in Dominican Republic?
Keep it short and to the point. -1.47e+1. In the year 2010, what is the difference between the Payments (BoP, current US$) in Albania and Payments (BoP, current US$) in Georgia?
Provide a short and direct response. -6.06e+08. In the year 2010, what is the difference between the Payments (BoP, current US$) of Albania and Payments (BoP, current US$) of United Kingdom?
Provide a succinct answer. -9.90e+11. In the year 2010, what is the difference between the Payments (BoP, current US$) in Dominican Republic and Payments (BoP, current US$) in Georgia?
Your response must be concise. 1.41e+1. In the year 2010, what is the difference between the Payments (BoP, current US$) in Dominican Republic and Payments (BoP, current US$) in United Kingdom?
Give a very brief answer. -9.76e+11. In the year 2010, what is the difference between the Payments (BoP, current US$) in Georgia and Payments (BoP, current US$) in United Kingdom?
Provide a succinct answer. -9.90e+11. In the year 2011, what is the difference between the Payments (BoP, current US$) in Albania and Payments (BoP, current US$) in Dominican Republic?
Your response must be concise. -1.61e+1. In the year 2011, what is the difference between the Payments (BoP, current US$) in Albania and Payments (BoP, current US$) in Georgia?
Provide a short and direct response. -2.16e+09. In the year 2011, what is the difference between the Payments (BoP, current US$) of Albania and Payments (BoP, current US$) of United Kingdom?
Offer a terse response. -1.13e+12. In the year 2011, what is the difference between the Payments (BoP, current US$) of Dominican Republic and Payments (BoP, current US$) of Georgia?
Provide a short and direct response. 1.39e+1. In the year 2011, what is the difference between the Payments (BoP, current US$) of Dominican Republic and Payments (BoP, current US$) of United Kingdom?
Provide a short and direct response. -1.11e+12. In the year 2011, what is the difference between the Payments (BoP, current US$) in Georgia and Payments (BoP, current US$) in United Kingdom?
Make the answer very short. -1.13e+12. In the year 2012, what is the difference between the Payments (BoP, current US$) of Albania and Payments (BoP, current US$) of Dominican Republic?
Keep it short and to the point. -1.74e+1. In the year 2012, what is the difference between the Payments (BoP, current US$) of Albania and Payments (BoP, current US$) of Georgia?
Provide a short and direct response. -4.17e+09. In the year 2012, what is the difference between the Payments (BoP, current US$) in Albania and Payments (BoP, current US$) in United Kingdom?
Offer a very short reply. -1.12e+12. In the year 2012, what is the difference between the Payments (BoP, current US$) of Dominican Republic and Payments (BoP, current US$) of Georgia?
Provide a short and direct response. 1.33e+1. In the year 2012, what is the difference between the Payments (BoP, current US$) in Dominican Republic and Payments (BoP, current US$) in United Kingdom?
Provide a short and direct response. -1.10e+12. In the year 2012, what is the difference between the Payments (BoP, current US$) in Georgia and Payments (BoP, current US$) in United Kingdom?
Your answer should be very brief. -1.12e+12. What is the ratio of the Payments (BoP, current US$) in Albania in 2006 to that in 2007?
Offer a very short reply. 0.76. What is the ratio of the Payments (BoP, current US$) of Dominican Republic in 2006 to that in 2007?
Offer a terse response. 0.86. What is the ratio of the Payments (BoP, current US$) of Georgia in 2006 to that in 2007?
Ensure brevity in your answer.  0.72. What is the ratio of the Payments (BoP, current US$) in United Kingdom in 2006 to that in 2007?
Your response must be concise. 0.85. What is the ratio of the Payments (BoP, current US$) in Albania in 2006 to that in 2008?
Ensure brevity in your answer.  0.58. What is the ratio of the Payments (BoP, current US$) in Dominican Republic in 2006 to that in 2008?
Your response must be concise. 0.76. What is the ratio of the Payments (BoP, current US$) in Georgia in 2006 to that in 2008?
Provide a succinct answer. 0.56. What is the ratio of the Payments (BoP, current US$) of United Kingdom in 2006 to that in 2008?
Give a very brief answer. 0.87. What is the ratio of the Payments (BoP, current US$) of Albania in 2006 to that in 2009?
Ensure brevity in your answer.  0.63. What is the ratio of the Payments (BoP, current US$) in Dominican Republic in 2006 to that in 2009?
Offer a very short reply. 0.98. What is the ratio of the Payments (BoP, current US$) of Georgia in 2006 to that in 2009?
Ensure brevity in your answer.  0.79. What is the ratio of the Payments (BoP, current US$) in United Kingdom in 2006 to that in 2009?
Provide a succinct answer. 1.29. What is the ratio of the Payments (BoP, current US$) of Albania in 2006 to that in 2010?
Keep it short and to the point. 0.66. What is the ratio of the Payments (BoP, current US$) of Dominican Republic in 2006 to that in 2010?
Provide a short and direct response. 0.65. What is the ratio of the Payments (BoP, current US$) of Georgia in 2006 to that in 2010?
Keep it short and to the point. 0.66. What is the ratio of the Payments (BoP, current US$) in United Kingdom in 2006 to that in 2010?
Your answer should be very brief. 1.22. What is the ratio of the Payments (BoP, current US$) in Albania in 2006 to that in 2011?
Provide a succinct answer. 0.59. What is the ratio of the Payments (BoP, current US$) in Dominican Republic in 2006 to that in 2011?
Make the answer very short. 0.59. What is the ratio of the Payments (BoP, current US$) of Georgia in 2006 to that in 2011?
Offer a very short reply. 0.5. What is the ratio of the Payments (BoP, current US$) in United Kingdom in 2006 to that in 2011?
Make the answer very short. 1.07. What is the ratio of the Payments (BoP, current US$) of Albania in 2006 to that in 2012?
Offer a terse response. 0.67. What is the ratio of the Payments (BoP, current US$) in Dominican Republic in 2006 to that in 2012?
Provide a short and direct response. 0.58. What is the ratio of the Payments (BoP, current US$) in Georgia in 2006 to that in 2012?
Your answer should be compact. 0.44. What is the ratio of the Payments (BoP, current US$) in United Kingdom in 2006 to that in 2012?
Provide a succinct answer. 1.08. What is the ratio of the Payments (BoP, current US$) in Albania in 2007 to that in 2008?
Offer a very short reply. 0.76. What is the ratio of the Payments (BoP, current US$) in Dominican Republic in 2007 to that in 2008?
Give a very brief answer. 0.88. What is the ratio of the Payments (BoP, current US$) in Georgia in 2007 to that in 2008?
Your response must be concise. 0.78. What is the ratio of the Payments (BoP, current US$) of United Kingdom in 2007 to that in 2008?
Ensure brevity in your answer.  1.02. What is the ratio of the Payments (BoP, current US$) in Albania in 2007 to that in 2009?
Make the answer very short. 0.82. What is the ratio of the Payments (BoP, current US$) in Dominican Republic in 2007 to that in 2009?
Offer a very short reply. 1.14. What is the ratio of the Payments (BoP, current US$) in Georgia in 2007 to that in 2009?
Your answer should be very brief. 1.09. What is the ratio of the Payments (BoP, current US$) of United Kingdom in 2007 to that in 2009?
Keep it short and to the point. 1.52. What is the ratio of the Payments (BoP, current US$) in Albania in 2007 to that in 2010?
Offer a very short reply. 0.86. What is the ratio of the Payments (BoP, current US$) of Dominican Republic in 2007 to that in 2010?
Ensure brevity in your answer.  0.76. What is the ratio of the Payments (BoP, current US$) of Georgia in 2007 to that in 2010?
Give a very brief answer. 0.92. What is the ratio of the Payments (BoP, current US$) in United Kingdom in 2007 to that in 2010?
Ensure brevity in your answer.  1.44. What is the ratio of the Payments (BoP, current US$) of Albania in 2007 to that in 2011?
Make the answer very short. 0.77. What is the ratio of the Payments (BoP, current US$) in Dominican Republic in 2007 to that in 2011?
Your response must be concise. 0.69. What is the ratio of the Payments (BoP, current US$) in Georgia in 2007 to that in 2011?
Your response must be concise. 0.69. What is the ratio of the Payments (BoP, current US$) of United Kingdom in 2007 to that in 2011?
Give a very brief answer. 1.27. What is the ratio of the Payments (BoP, current US$) of Albania in 2007 to that in 2012?
Provide a succinct answer. 0.88. What is the ratio of the Payments (BoP, current US$) of Dominican Republic in 2007 to that in 2012?
Keep it short and to the point. 0.67. What is the ratio of the Payments (BoP, current US$) of Georgia in 2007 to that in 2012?
Provide a short and direct response. 0.61. What is the ratio of the Payments (BoP, current US$) of United Kingdom in 2007 to that in 2012?
Offer a terse response. 1.28. What is the ratio of the Payments (BoP, current US$) of Albania in 2008 to that in 2009?
Keep it short and to the point. 1.08. What is the ratio of the Payments (BoP, current US$) in Dominican Republic in 2008 to that in 2009?
Make the answer very short. 1.29. What is the ratio of the Payments (BoP, current US$) of Georgia in 2008 to that in 2009?
Offer a terse response. 1.4. What is the ratio of the Payments (BoP, current US$) of United Kingdom in 2008 to that in 2009?
Your answer should be very brief. 1.49. What is the ratio of the Payments (BoP, current US$) in Albania in 2008 to that in 2010?
Your response must be concise. 1.14. What is the ratio of the Payments (BoP, current US$) of Dominican Republic in 2008 to that in 2010?
Offer a terse response. 0.86. What is the ratio of the Payments (BoP, current US$) in Georgia in 2008 to that in 2010?
Make the answer very short. 1.18. What is the ratio of the Payments (BoP, current US$) of United Kingdom in 2008 to that in 2010?
Offer a very short reply. 1.41. What is the ratio of the Payments (BoP, current US$) of Albania in 2008 to that in 2011?
Offer a terse response. 1.02. What is the ratio of the Payments (BoP, current US$) in Dominican Republic in 2008 to that in 2011?
Make the answer very short. 0.78. What is the ratio of the Payments (BoP, current US$) in Georgia in 2008 to that in 2011?
Ensure brevity in your answer.  0.89. What is the ratio of the Payments (BoP, current US$) in United Kingdom in 2008 to that in 2011?
Offer a terse response. 1.24. What is the ratio of the Payments (BoP, current US$) in Albania in 2008 to that in 2012?
Your response must be concise. 1.16. What is the ratio of the Payments (BoP, current US$) in Dominican Republic in 2008 to that in 2012?
Make the answer very short. 0.76. What is the ratio of the Payments (BoP, current US$) of Georgia in 2008 to that in 2012?
Keep it short and to the point. 0.78. What is the ratio of the Payments (BoP, current US$) of United Kingdom in 2008 to that in 2012?
Your answer should be very brief. 1.25. What is the ratio of the Payments (BoP, current US$) of Albania in 2009 to that in 2010?
Ensure brevity in your answer.  1.05. What is the ratio of the Payments (BoP, current US$) of Dominican Republic in 2009 to that in 2010?
Your answer should be very brief. 0.67. What is the ratio of the Payments (BoP, current US$) in Georgia in 2009 to that in 2010?
Provide a short and direct response. 0.84. What is the ratio of the Payments (BoP, current US$) of United Kingdom in 2009 to that in 2010?
Ensure brevity in your answer.  0.95. What is the ratio of the Payments (BoP, current US$) in Dominican Republic in 2009 to that in 2011?
Provide a succinct answer. 0.61. What is the ratio of the Payments (BoP, current US$) in Georgia in 2009 to that in 2011?
Your response must be concise. 0.63. What is the ratio of the Payments (BoP, current US$) in United Kingdom in 2009 to that in 2011?
Offer a very short reply. 0.83. What is the ratio of the Payments (BoP, current US$) in Albania in 2009 to that in 2012?
Make the answer very short. 1.07. What is the ratio of the Payments (BoP, current US$) in Dominican Republic in 2009 to that in 2012?
Offer a very short reply. 0.59. What is the ratio of the Payments (BoP, current US$) of Georgia in 2009 to that in 2012?
Offer a very short reply. 0.56. What is the ratio of the Payments (BoP, current US$) of United Kingdom in 2009 to that in 2012?
Provide a succinct answer. 0.84. What is the ratio of the Payments (BoP, current US$) of Albania in 2010 to that in 2011?
Ensure brevity in your answer.  0.9. What is the ratio of the Payments (BoP, current US$) of Dominican Republic in 2010 to that in 2011?
Keep it short and to the point. 0.91. What is the ratio of the Payments (BoP, current US$) in Georgia in 2010 to that in 2011?
Ensure brevity in your answer.  0.75. What is the ratio of the Payments (BoP, current US$) of United Kingdom in 2010 to that in 2011?
Ensure brevity in your answer.  0.88. What is the ratio of the Payments (BoP, current US$) in Albania in 2010 to that in 2012?
Offer a terse response. 1.01. What is the ratio of the Payments (BoP, current US$) of Dominican Republic in 2010 to that in 2012?
Make the answer very short. 0.89. What is the ratio of the Payments (BoP, current US$) in Georgia in 2010 to that in 2012?
Give a very brief answer. 0.66. What is the ratio of the Payments (BoP, current US$) in United Kingdom in 2010 to that in 2012?
Give a very brief answer. 0.89. What is the ratio of the Payments (BoP, current US$) in Albania in 2011 to that in 2012?
Make the answer very short. 1.13. What is the ratio of the Payments (BoP, current US$) in Dominican Republic in 2011 to that in 2012?
Your answer should be compact. 0.98. What is the ratio of the Payments (BoP, current US$) of Georgia in 2011 to that in 2012?
Provide a succinct answer. 0.89. What is the ratio of the Payments (BoP, current US$) in United Kingdom in 2011 to that in 2012?
Your response must be concise. 1.01. What is the difference between the highest and the second highest Payments (BoP, current US$) in Albania?
Give a very brief answer. 1.39e+08. What is the difference between the highest and the second highest Payments (BoP, current US$) in Dominican Republic?
Offer a terse response. 5.53e+08. What is the difference between the highest and the second highest Payments (BoP, current US$) of Georgia?
Offer a very short reply. 1.19e+09. What is the difference between the highest and the second highest Payments (BoP, current US$) of United Kingdom?
Offer a very short reply. 3.47e+1. What is the difference between the highest and the lowest Payments (BoP, current US$) of Albania?
Your answer should be very brief. 3.01e+09. What is the difference between the highest and the lowest Payments (BoP, current US$) of Dominican Republic?
Keep it short and to the point. 9.91e+09. What is the difference between the highest and the lowest Payments (BoP, current US$) of Georgia?
Keep it short and to the point. 5.80e+09. What is the difference between the highest and the lowest Payments (BoP, current US$) of United Kingdom?
Your answer should be compact. 4.94e+11. 